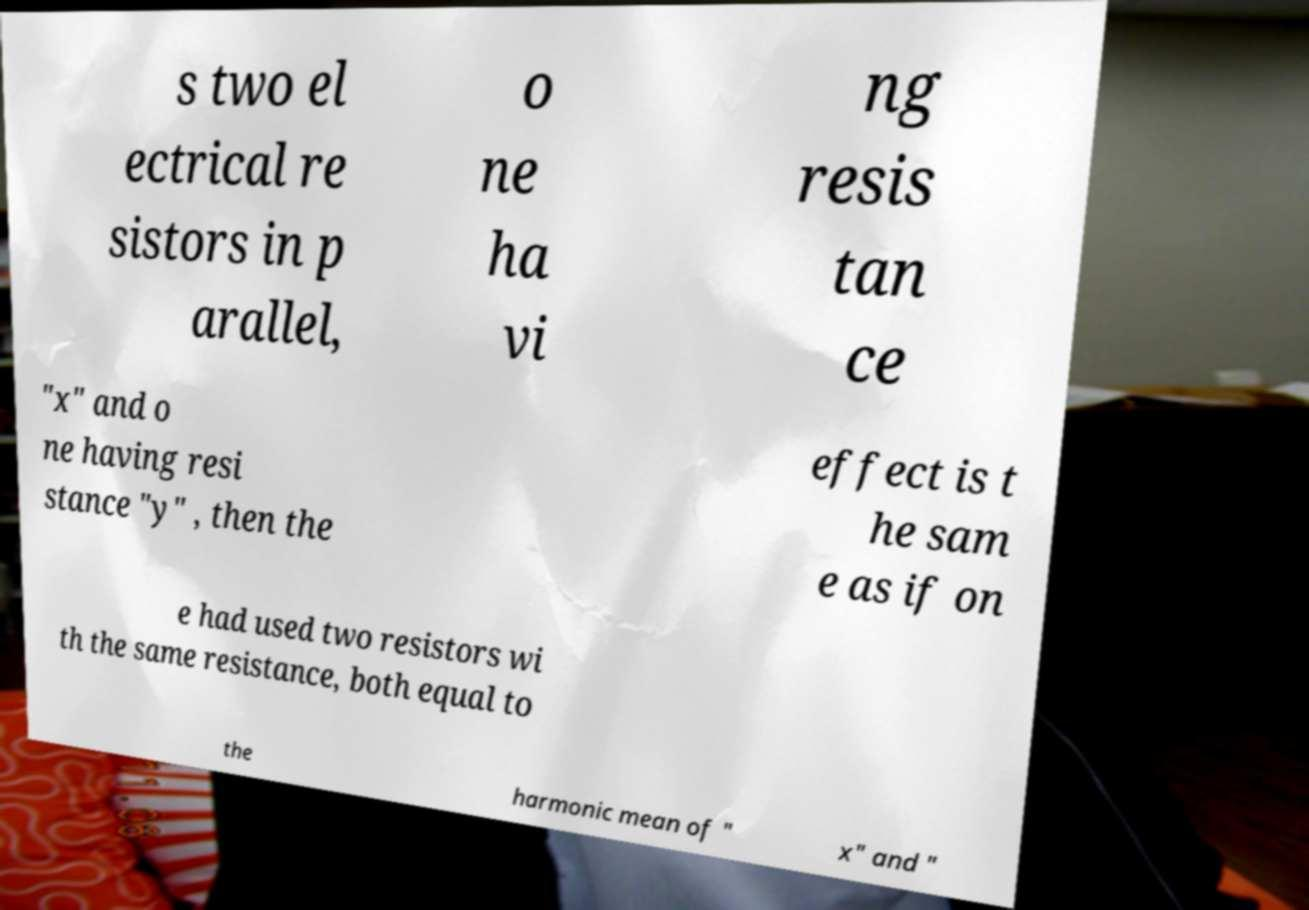Can you read and provide the text displayed in the image?This photo seems to have some interesting text. Can you extract and type it out for me? s two el ectrical re sistors in p arallel, o ne ha vi ng resis tan ce "x" and o ne having resi stance "y" , then the effect is t he sam e as if on e had used two resistors wi th the same resistance, both equal to the harmonic mean of " x" and " 